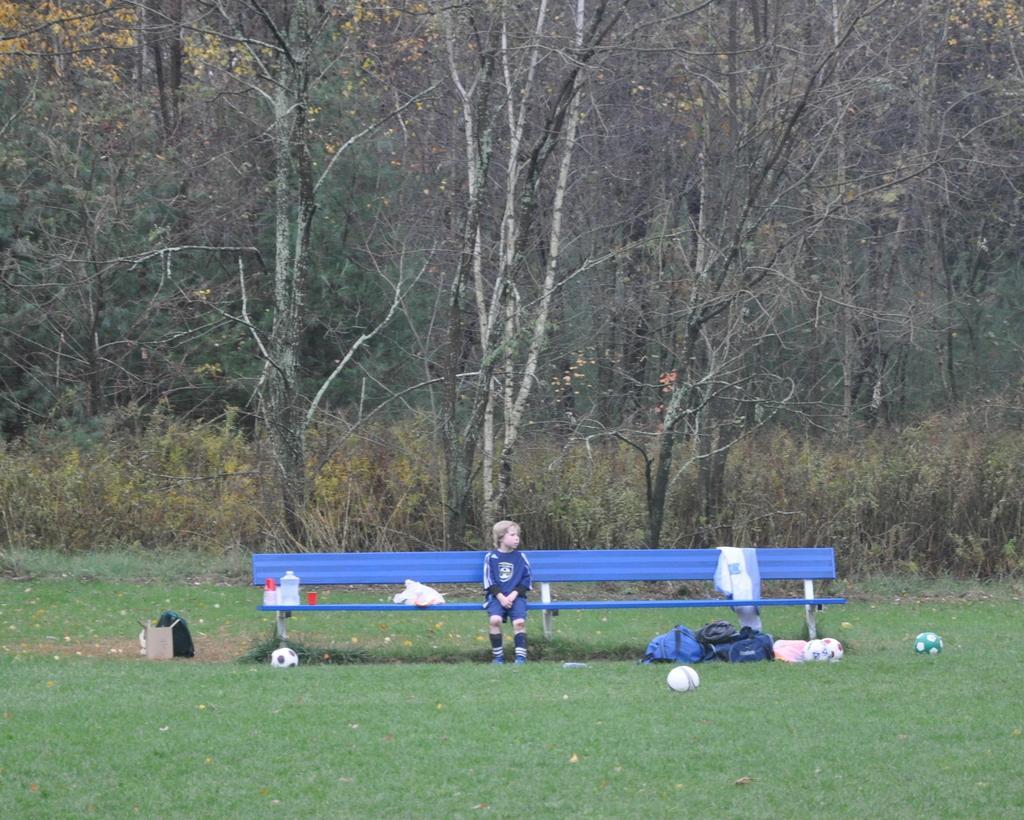In one or two sentences, can you explain what this image depicts? In this picture we can see a child sitting on a bench, bags, balls, grass and in the background we can see trees. 